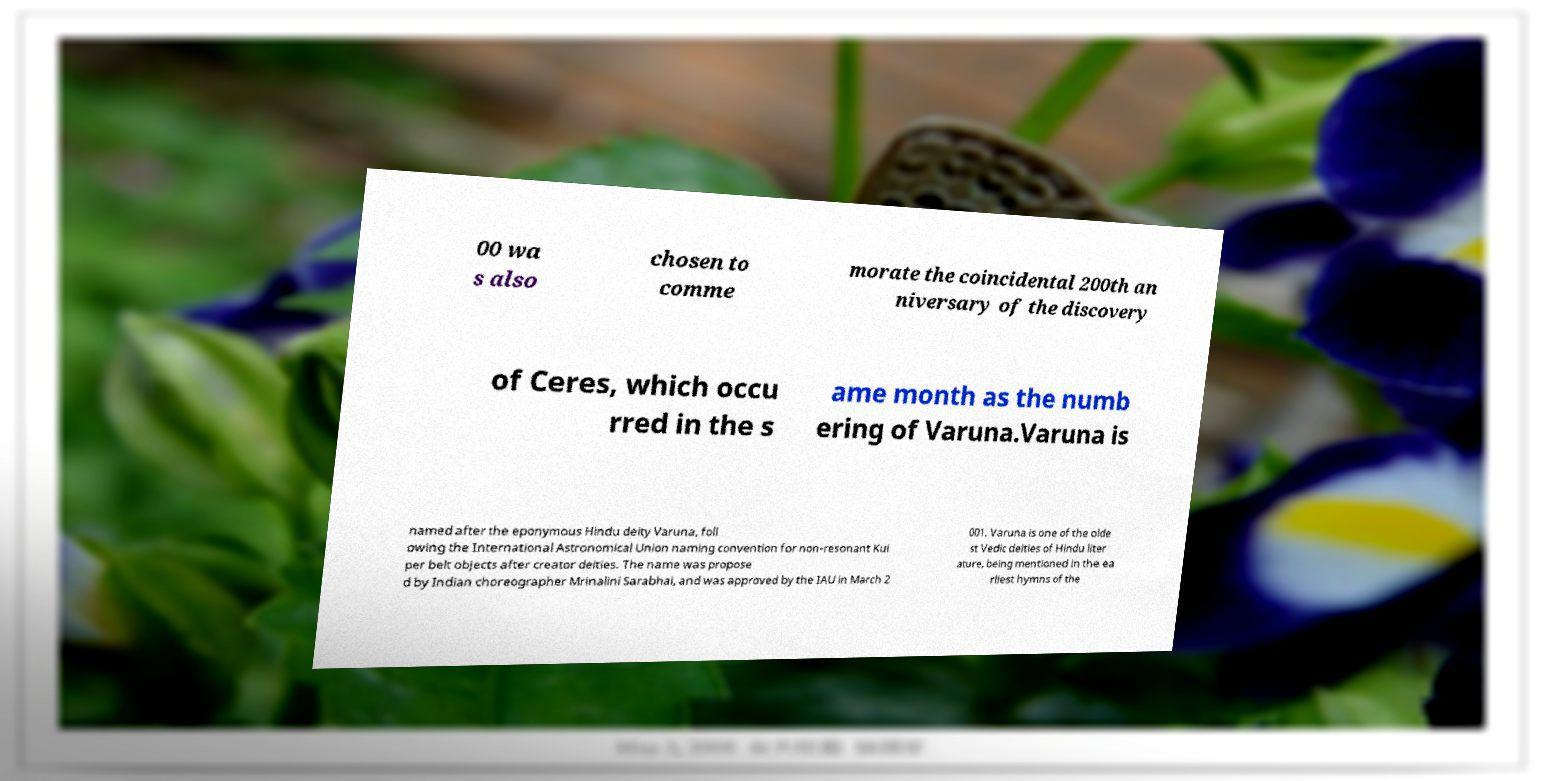Could you assist in decoding the text presented in this image and type it out clearly? 00 wa s also chosen to comme morate the coincidental 200th an niversary of the discovery of Ceres, which occu rred in the s ame month as the numb ering of Varuna.Varuna is named after the eponymous Hindu deity Varuna, foll owing the International Astronomical Union naming convention for non-resonant Kui per belt objects after creator deities. The name was propose d by Indian choreographer Mrinalini Sarabhai, and was approved by the IAU in March 2 001. Varuna is one of the olde st Vedic deities of Hindu liter ature, being mentioned in the ea rliest hymns of the 